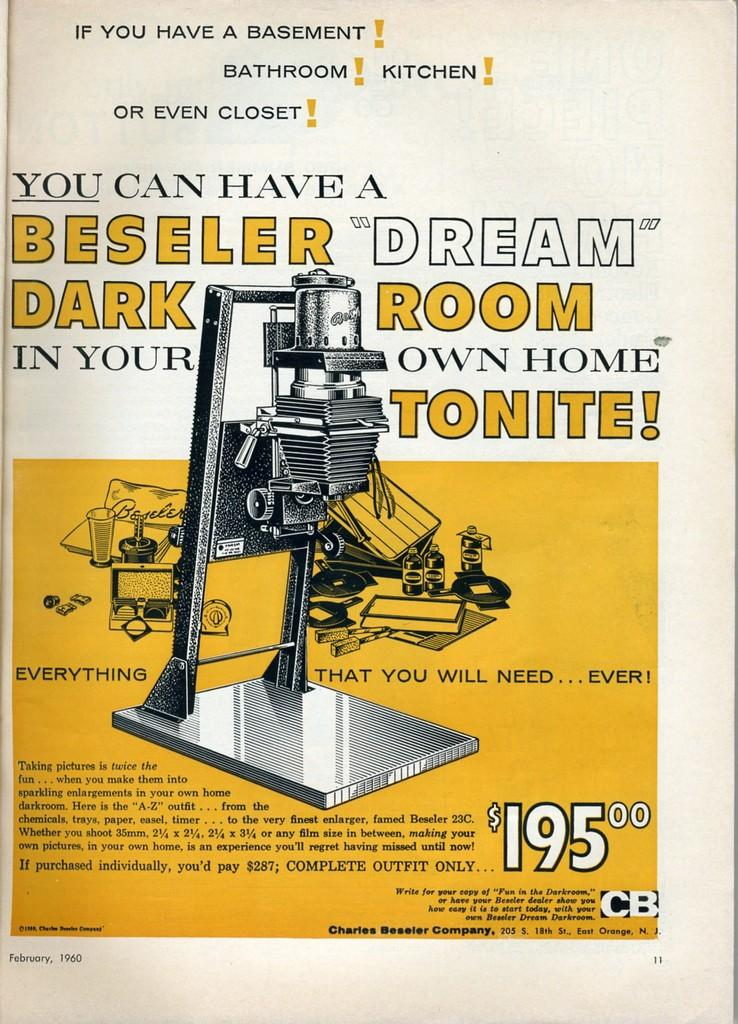<image>
Provide a brief description of the given image. Ad for a Beseller Dark that is in yellow and white. 